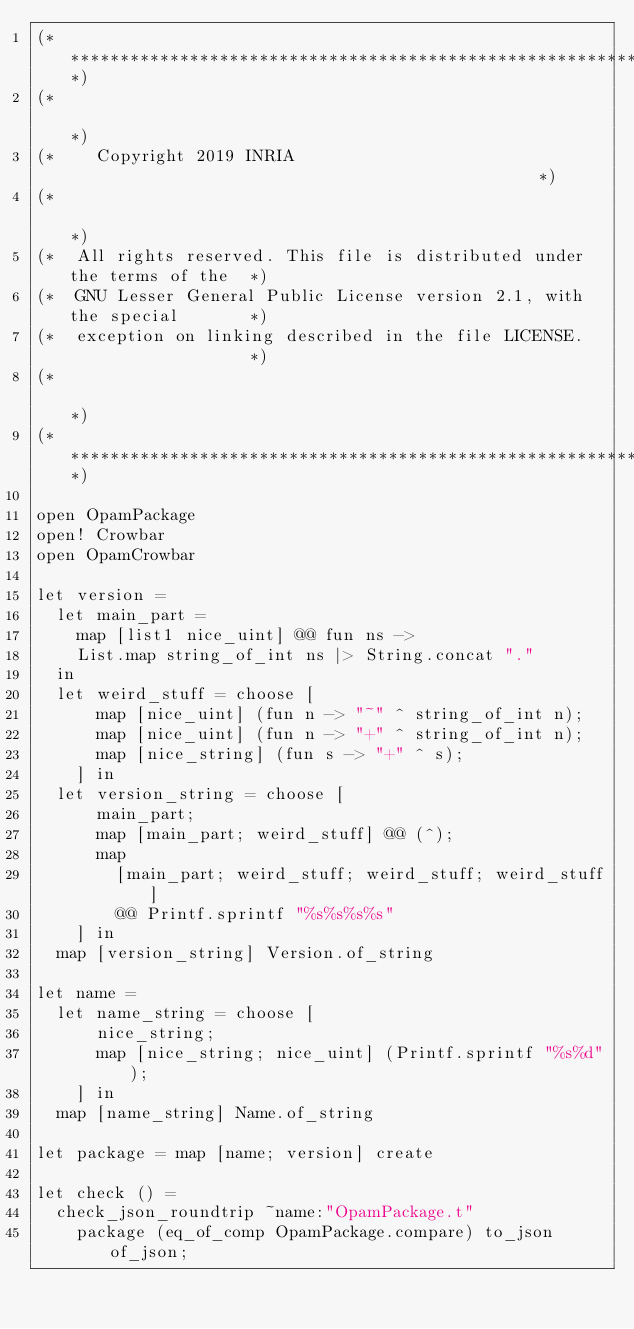Convert code to text. <code><loc_0><loc_0><loc_500><loc_500><_OCaml_>(**************************************************************************)
(*                                                                        *)
(*    Copyright 2019 INRIA                                                *)
(*                                                                        *)
(*  All rights reserved. This file is distributed under the terms of the  *)
(*  GNU Lesser General Public License version 2.1, with the special       *)
(*  exception on linking described in the file LICENSE.                   *)
(*                                                                        *)
(**************************************************************************)

open OpamPackage
open! Crowbar
open OpamCrowbar

let version =
  let main_part =
    map [list1 nice_uint] @@ fun ns ->
    List.map string_of_int ns |> String.concat "."
  in
  let weird_stuff = choose [
      map [nice_uint] (fun n -> "~" ^ string_of_int n);
      map [nice_uint] (fun n -> "+" ^ string_of_int n);
      map [nice_string] (fun s -> "+" ^ s);
    ] in
  let version_string = choose [
      main_part;
      map [main_part; weird_stuff] @@ (^);
      map
        [main_part; weird_stuff; weird_stuff; weird_stuff]
        @@ Printf.sprintf "%s%s%s%s"
    ] in
  map [version_string] Version.of_string

let name =
  let name_string = choose [
      nice_string;
      map [nice_string; nice_uint] (Printf.sprintf "%s%d");
    ] in
  map [name_string] Name.of_string

let package = map [name; version] create
  
let check () =
  check_json_roundtrip ~name:"OpamPackage.t"
    package (eq_of_comp OpamPackage.compare) to_json of_json;
</code> 